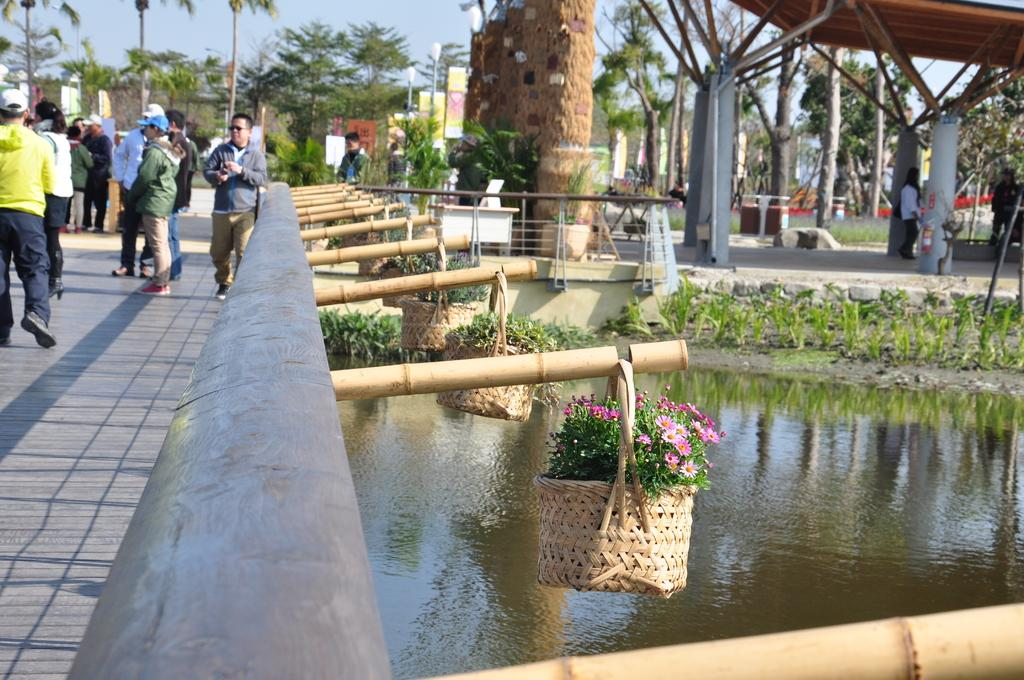What objects in the image contain flowers? There are baskets with flowers in the image. What natural element is visible in the image? There is water visible in the image. What type of vegetation is present in the image? There are plants and trees in the image. What type of structure can be seen in the image? There is an open shed in the image. Can you describe the people in the image? There are people in the image, but their specific actions or characteristics are not mentioned in the provided facts. Can you tell me how many ants are crawling on the flowers in the image? There is no mention of ants in the image, so it is not possible to determine their presence or number. Is there a crib visible in the image? There is no crib present in the image. 